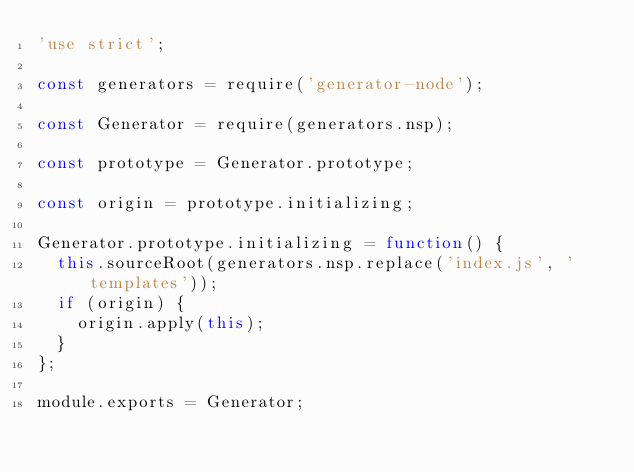Convert code to text. <code><loc_0><loc_0><loc_500><loc_500><_JavaScript_>'use strict';

const generators = require('generator-node');

const Generator = require(generators.nsp);

const prototype = Generator.prototype;

const origin = prototype.initializing;

Generator.prototype.initializing = function() {
  this.sourceRoot(generators.nsp.replace('index.js', 'templates'));
  if (origin) {
    origin.apply(this);
  }
};

module.exports = Generator;
</code> 